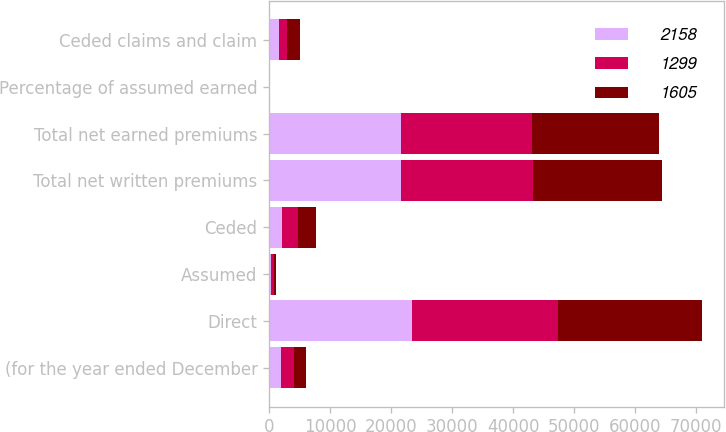Convert chart to OTSL. <chart><loc_0><loc_0><loc_500><loc_500><stacked_bar_chart><ecel><fcel>(for the year ended December<fcel>Direct<fcel>Assumed<fcel>Ceded<fcel>Total net written premiums<fcel>Total net earned premiums<fcel>Percentage of assumed earned<fcel>Ceded claims and claim<nl><fcel>2158<fcel>2008<fcel>23469<fcel>368<fcel>2154<fcel>21683<fcel>21579<fcel>1.8<fcel>1605<nl><fcel>1299<fcel>2007<fcel>23824<fcel>374<fcel>2580<fcel>21618<fcel>21470<fcel>0.8<fcel>1299<nl><fcel>1605<fcel>2006<fcel>23635<fcel>404<fcel>2889<fcel>21150<fcel>20760<fcel>2.3<fcel>2158<nl></chart> 